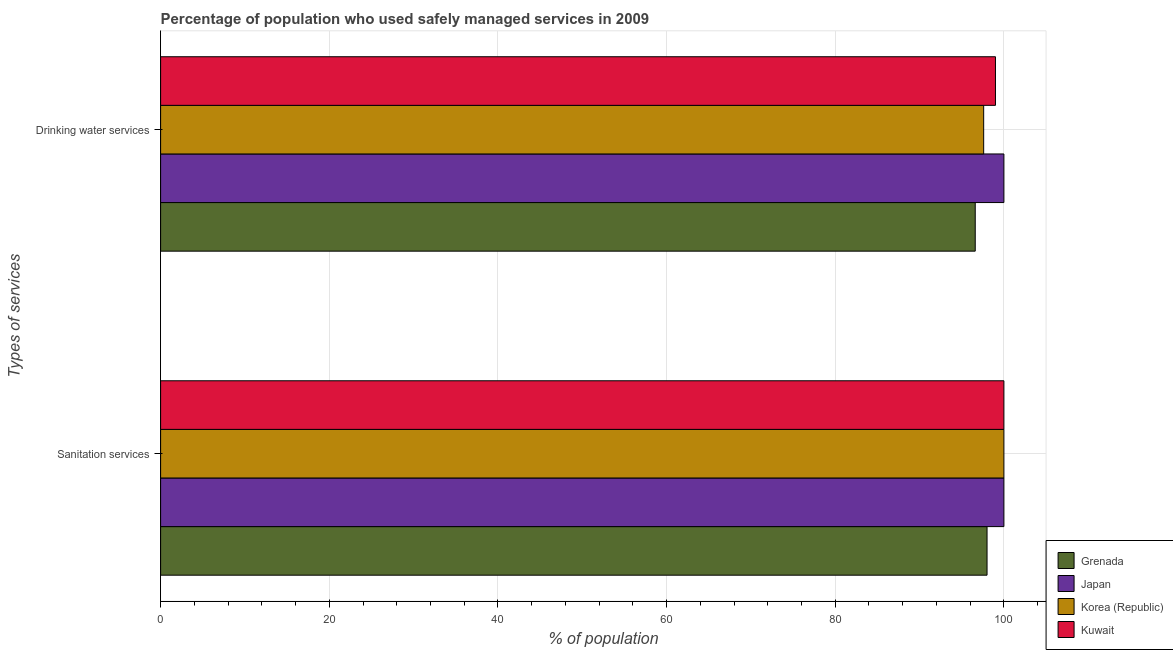How many bars are there on the 2nd tick from the top?
Provide a short and direct response. 4. How many bars are there on the 2nd tick from the bottom?
Offer a terse response. 4. What is the label of the 1st group of bars from the top?
Offer a very short reply. Drinking water services. What is the percentage of population who used sanitation services in Japan?
Provide a succinct answer. 100. Across all countries, what is the minimum percentage of population who used sanitation services?
Your response must be concise. 98. In which country was the percentage of population who used sanitation services minimum?
Make the answer very short. Grenada. What is the total percentage of population who used drinking water services in the graph?
Make the answer very short. 393.2. What is the difference between the percentage of population who used sanitation services in Grenada and that in Japan?
Offer a very short reply. -2. What is the difference between the percentage of population who used drinking water services in Kuwait and the percentage of population who used sanitation services in Japan?
Offer a very short reply. -1. What is the average percentage of population who used sanitation services per country?
Keep it short and to the point. 99.5. What is the difference between the percentage of population who used drinking water services and percentage of population who used sanitation services in Grenada?
Make the answer very short. -1.4. In how many countries, is the percentage of population who used drinking water services greater than 60 %?
Your response must be concise. 4. What is the ratio of the percentage of population who used drinking water services in Grenada to that in Korea (Republic)?
Offer a very short reply. 0.99. In how many countries, is the percentage of population who used drinking water services greater than the average percentage of population who used drinking water services taken over all countries?
Ensure brevity in your answer.  2. What does the 4th bar from the top in Drinking water services represents?
Ensure brevity in your answer.  Grenada. What does the 2nd bar from the bottom in Drinking water services represents?
Make the answer very short. Japan. What is the difference between two consecutive major ticks on the X-axis?
Provide a succinct answer. 20. Are the values on the major ticks of X-axis written in scientific E-notation?
Your answer should be very brief. No. Does the graph contain any zero values?
Your answer should be very brief. No. Where does the legend appear in the graph?
Your answer should be very brief. Bottom right. What is the title of the graph?
Your answer should be very brief. Percentage of population who used safely managed services in 2009. What is the label or title of the X-axis?
Provide a succinct answer. % of population. What is the label or title of the Y-axis?
Make the answer very short. Types of services. What is the % of population of Grenada in Sanitation services?
Provide a succinct answer. 98. What is the % of population in Japan in Sanitation services?
Offer a very short reply. 100. What is the % of population in Grenada in Drinking water services?
Provide a short and direct response. 96.6. What is the % of population of Korea (Republic) in Drinking water services?
Your answer should be very brief. 97.6. Across all Types of services, what is the maximum % of population of Grenada?
Provide a succinct answer. 98. Across all Types of services, what is the maximum % of population in Kuwait?
Provide a succinct answer. 100. Across all Types of services, what is the minimum % of population in Grenada?
Your response must be concise. 96.6. Across all Types of services, what is the minimum % of population of Korea (Republic)?
Provide a short and direct response. 97.6. Across all Types of services, what is the minimum % of population in Kuwait?
Give a very brief answer. 99. What is the total % of population of Grenada in the graph?
Give a very brief answer. 194.6. What is the total % of population of Korea (Republic) in the graph?
Offer a very short reply. 197.6. What is the total % of population of Kuwait in the graph?
Your answer should be very brief. 199. What is the difference between the % of population of Japan in Sanitation services and that in Drinking water services?
Your answer should be compact. 0. What is the difference between the % of population in Japan in Sanitation services and the % of population in Kuwait in Drinking water services?
Make the answer very short. 1. What is the difference between the % of population of Korea (Republic) in Sanitation services and the % of population of Kuwait in Drinking water services?
Offer a terse response. 1. What is the average % of population in Grenada per Types of services?
Give a very brief answer. 97.3. What is the average % of population in Korea (Republic) per Types of services?
Give a very brief answer. 98.8. What is the average % of population in Kuwait per Types of services?
Ensure brevity in your answer.  99.5. What is the difference between the % of population of Grenada and % of population of Korea (Republic) in Sanitation services?
Your response must be concise. -2. What is the difference between the % of population in Japan and % of population in Korea (Republic) in Sanitation services?
Offer a very short reply. 0. What is the difference between the % of population in Japan and % of population in Kuwait in Sanitation services?
Make the answer very short. 0. What is the difference between the % of population in Korea (Republic) and % of population in Kuwait in Sanitation services?
Offer a terse response. 0. What is the difference between the % of population of Grenada and % of population of Kuwait in Drinking water services?
Offer a terse response. -2.4. What is the difference between the % of population of Japan and % of population of Korea (Republic) in Drinking water services?
Ensure brevity in your answer.  2.4. What is the difference between the % of population in Japan and % of population in Kuwait in Drinking water services?
Give a very brief answer. 1. What is the ratio of the % of population of Grenada in Sanitation services to that in Drinking water services?
Make the answer very short. 1.01. What is the ratio of the % of population of Japan in Sanitation services to that in Drinking water services?
Provide a succinct answer. 1. What is the ratio of the % of population of Korea (Republic) in Sanitation services to that in Drinking water services?
Make the answer very short. 1.02. What is the ratio of the % of population of Kuwait in Sanitation services to that in Drinking water services?
Give a very brief answer. 1.01. What is the difference between the highest and the second highest % of population of Grenada?
Your answer should be very brief. 1.4. What is the difference between the highest and the second highest % of population in Japan?
Your answer should be compact. 0. What is the difference between the highest and the lowest % of population in Grenada?
Ensure brevity in your answer.  1.4. What is the difference between the highest and the lowest % of population of Korea (Republic)?
Ensure brevity in your answer.  2.4. 